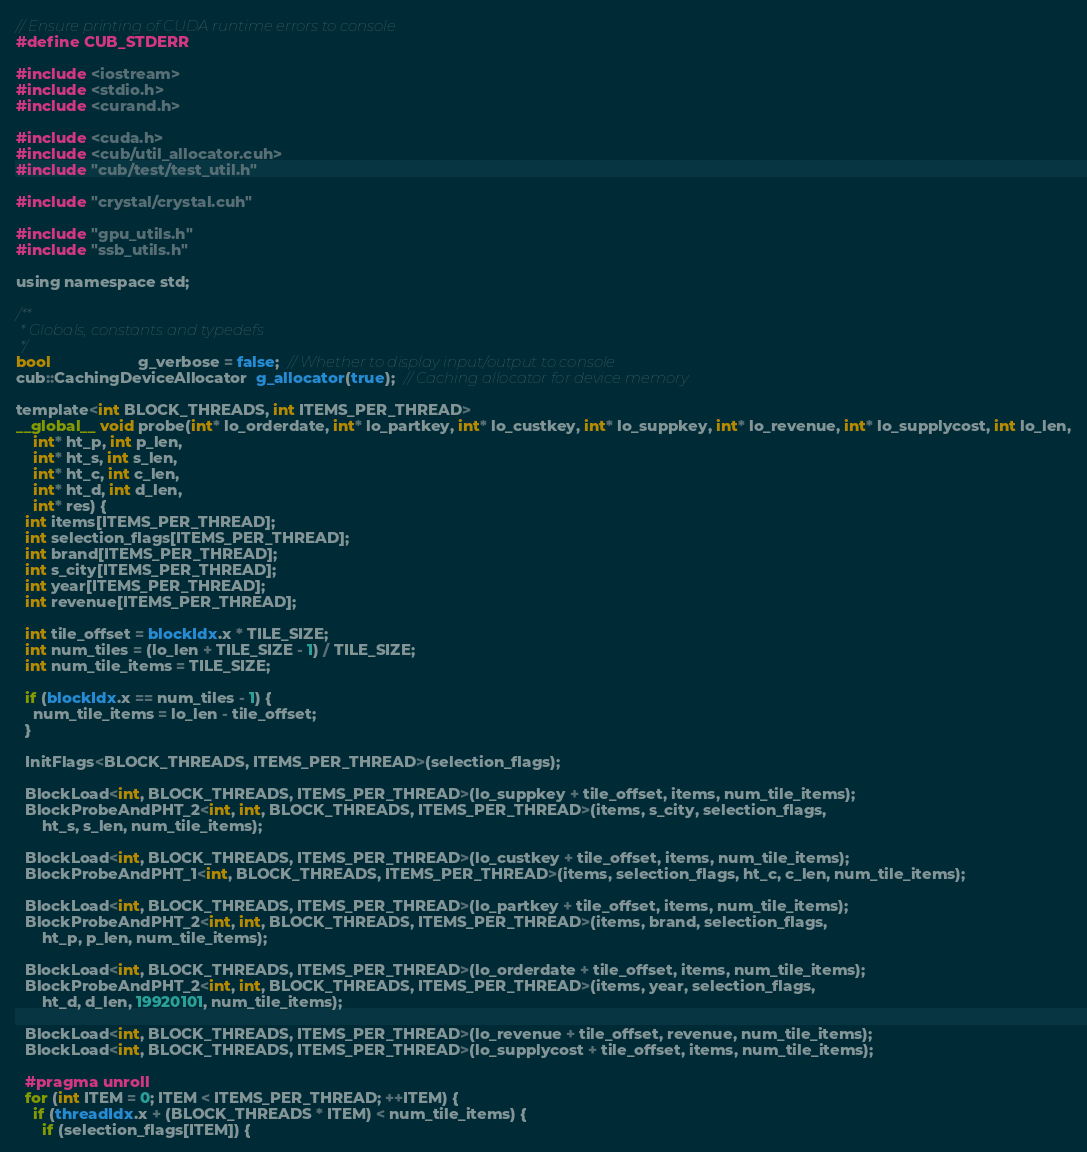Convert code to text. <code><loc_0><loc_0><loc_500><loc_500><_Cuda_>// Ensure printing of CUDA runtime errors to console
#define CUB_STDERR

#include <iostream>
#include <stdio.h>
#include <curand.h>

#include <cuda.h>
#include <cub/util_allocator.cuh>
#include "cub/test/test_util.h"

#include "crystal/crystal.cuh"

#include "gpu_utils.h"
#include "ssb_utils.h"

using namespace std;

/**
 * Globals, constants and typedefs
 */
bool                    g_verbose = false;  // Whether to display input/output to console
cub::CachingDeviceAllocator  g_allocator(true);  // Caching allocator for device memory

template<int BLOCK_THREADS, int ITEMS_PER_THREAD>
__global__ void probe(int* lo_orderdate, int* lo_partkey, int* lo_custkey, int* lo_suppkey, int* lo_revenue, int* lo_supplycost, int lo_len,
    int* ht_p, int p_len,
    int* ht_s, int s_len,
    int* ht_c, int c_len,
    int* ht_d, int d_len,
    int* res) {
  int items[ITEMS_PER_THREAD];
  int selection_flags[ITEMS_PER_THREAD];
  int brand[ITEMS_PER_THREAD];
  int s_city[ITEMS_PER_THREAD];
  int year[ITEMS_PER_THREAD];
  int revenue[ITEMS_PER_THREAD];

  int tile_offset = blockIdx.x * TILE_SIZE;
  int num_tiles = (lo_len + TILE_SIZE - 1) / TILE_SIZE;
  int num_tile_items = TILE_SIZE;

  if (blockIdx.x == num_tiles - 1) {
    num_tile_items = lo_len - tile_offset;
  }

  InitFlags<BLOCK_THREADS, ITEMS_PER_THREAD>(selection_flags);

  BlockLoad<int, BLOCK_THREADS, ITEMS_PER_THREAD>(lo_suppkey + tile_offset, items, num_tile_items);
  BlockProbeAndPHT_2<int, int, BLOCK_THREADS, ITEMS_PER_THREAD>(items, s_city, selection_flags,
      ht_s, s_len, num_tile_items);

  BlockLoad<int, BLOCK_THREADS, ITEMS_PER_THREAD>(lo_custkey + tile_offset, items, num_tile_items);
  BlockProbeAndPHT_1<int, BLOCK_THREADS, ITEMS_PER_THREAD>(items, selection_flags, ht_c, c_len, num_tile_items);

  BlockLoad<int, BLOCK_THREADS, ITEMS_PER_THREAD>(lo_partkey + tile_offset, items, num_tile_items);
  BlockProbeAndPHT_2<int, int, BLOCK_THREADS, ITEMS_PER_THREAD>(items, brand, selection_flags,
      ht_p, p_len, num_tile_items);

  BlockLoad<int, BLOCK_THREADS, ITEMS_PER_THREAD>(lo_orderdate + tile_offset, items, num_tile_items);
  BlockProbeAndPHT_2<int, int, BLOCK_THREADS, ITEMS_PER_THREAD>(items, year, selection_flags,
      ht_d, d_len, 19920101, num_tile_items);

  BlockLoad<int, BLOCK_THREADS, ITEMS_PER_THREAD>(lo_revenue + tile_offset, revenue, num_tile_items);
  BlockLoad<int, BLOCK_THREADS, ITEMS_PER_THREAD>(lo_supplycost + tile_offset, items, num_tile_items);

  #pragma unroll
  for (int ITEM = 0; ITEM < ITEMS_PER_THREAD; ++ITEM) {
    if (threadIdx.x + (BLOCK_THREADS * ITEM) < num_tile_items) {
      if (selection_flags[ITEM]) {</code> 